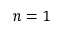Convert formula to latex. <formula><loc_0><loc_0><loc_500><loc_500>n = 1</formula> 